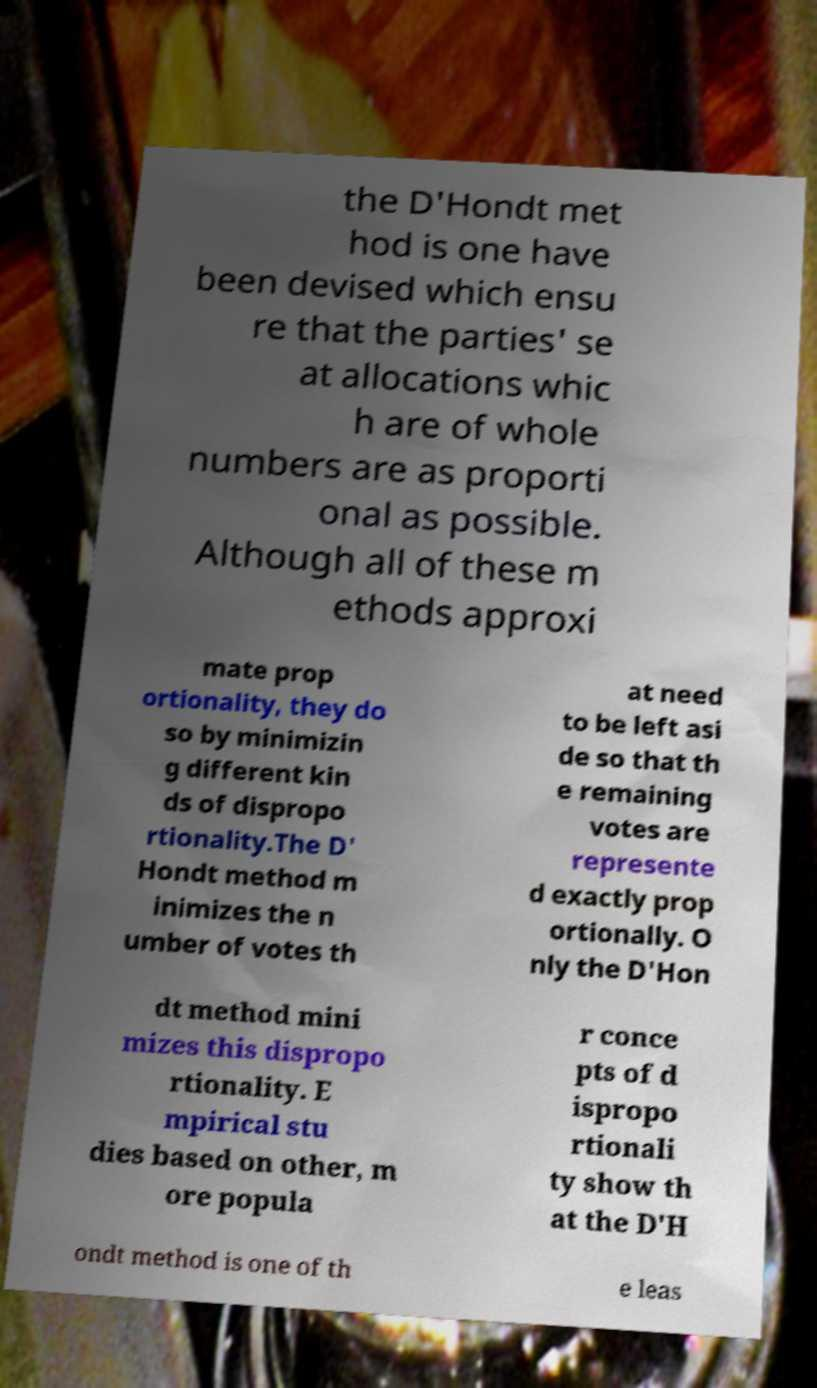What messages or text are displayed in this image? I need them in a readable, typed format. the D'Hondt met hod is one have been devised which ensu re that the parties' se at allocations whic h are of whole numbers are as proporti onal as possible. Although all of these m ethods approxi mate prop ortionality, they do so by minimizin g different kin ds of dispropo rtionality.The D' Hondt method m inimizes the n umber of votes th at need to be left asi de so that th e remaining votes are represente d exactly prop ortionally. O nly the D'Hon dt method mini mizes this dispropo rtionality. E mpirical stu dies based on other, m ore popula r conce pts of d ispropo rtionali ty show th at the D'H ondt method is one of th e leas 